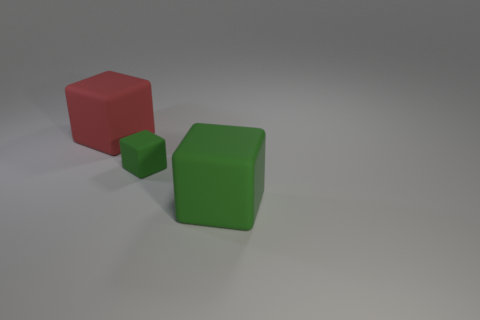There is a big green thing that is the same shape as the large red rubber thing; what is it made of?
Ensure brevity in your answer.  Rubber. What number of cyan things are the same size as the red block?
Provide a short and direct response. 0. There is a tiny block that is the same material as the big green thing; what color is it?
Your answer should be very brief. Green. Are there fewer large red rubber objects than cyan things?
Keep it short and to the point. No. What number of purple things are either rubber objects or tiny cubes?
Your answer should be compact. 0. How many rubber objects are both behind the large green matte thing and in front of the large red rubber block?
Provide a short and direct response. 1. Are the large red cube and the big green cube made of the same material?
Offer a very short reply. Yes. What shape is the other thing that is the same size as the red matte thing?
Ensure brevity in your answer.  Cube. Are there more tiny red metallic things than big things?
Offer a very short reply. No. The object that is to the left of the large green cube and to the right of the red rubber block is made of what material?
Offer a very short reply. Rubber. 